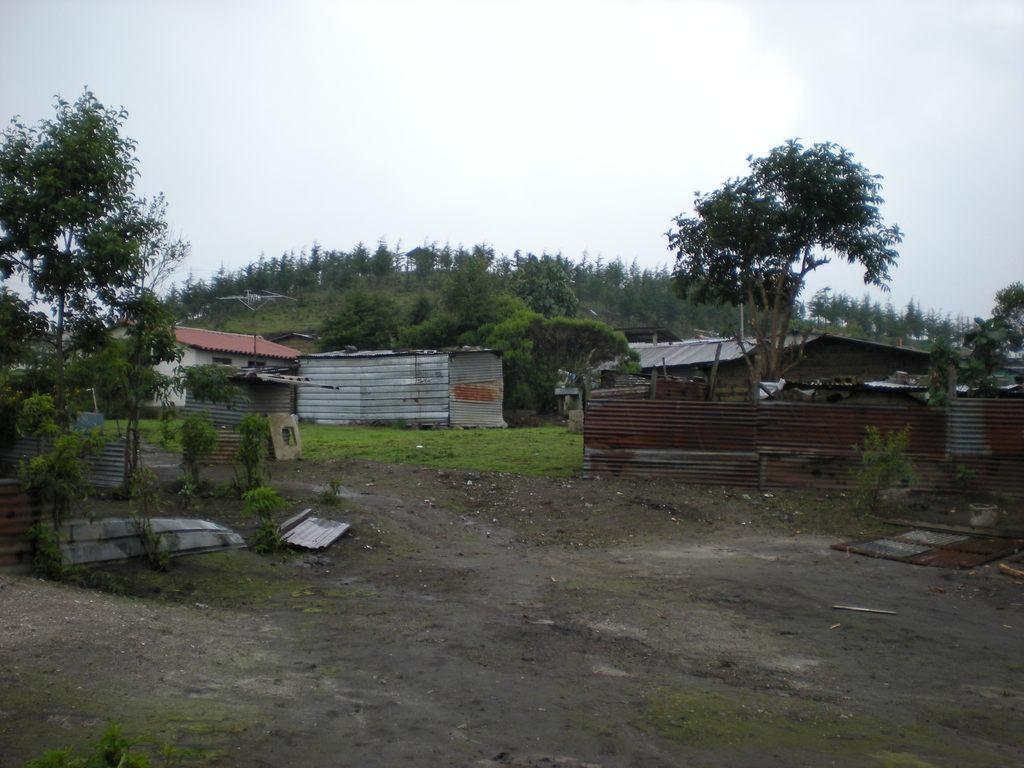What can be seen at the bottom of the image? The ground is visible in the image. What type of structures are present in the image? There are houses in the image. What is covering the top of the houses? Roof sheets are present in the image. What type of vegetation is visible in the image? Trees are visible in the image. What is visible in the background of the image? The sky is visible in the background of the image. What type of song can be heard playing in the background of the image? There is no sound or music present in the image, so it is not possible to determine what song might be heard. 